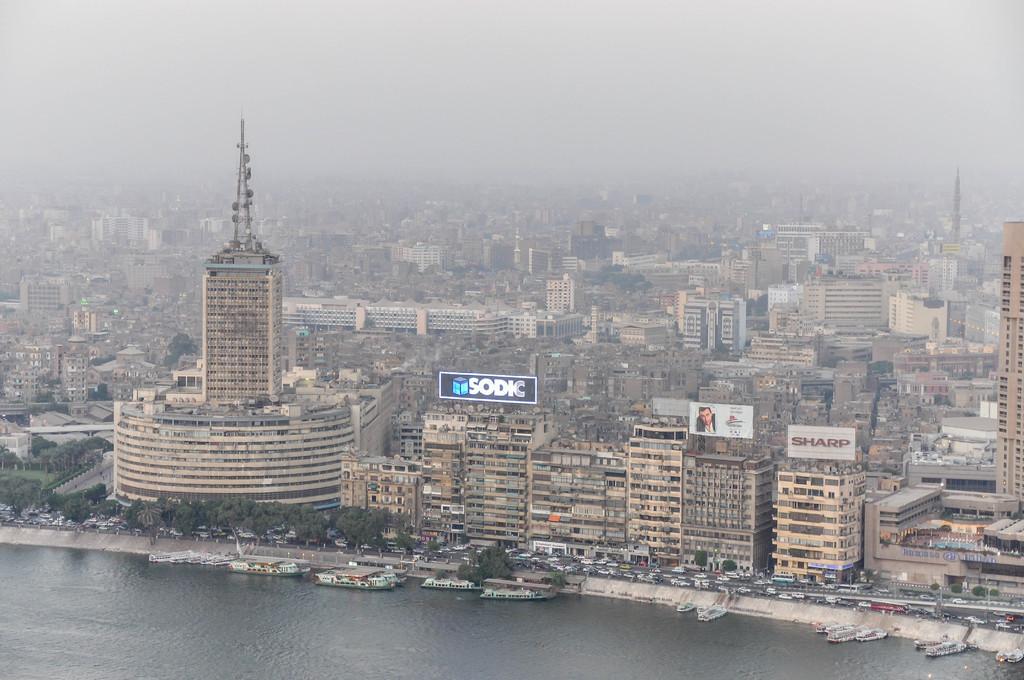Describe this image in one or two sentences. In this picture there is a view of the city from the top. In the front there are some buildings. In the front bottom side there is a river water with white color boats. 